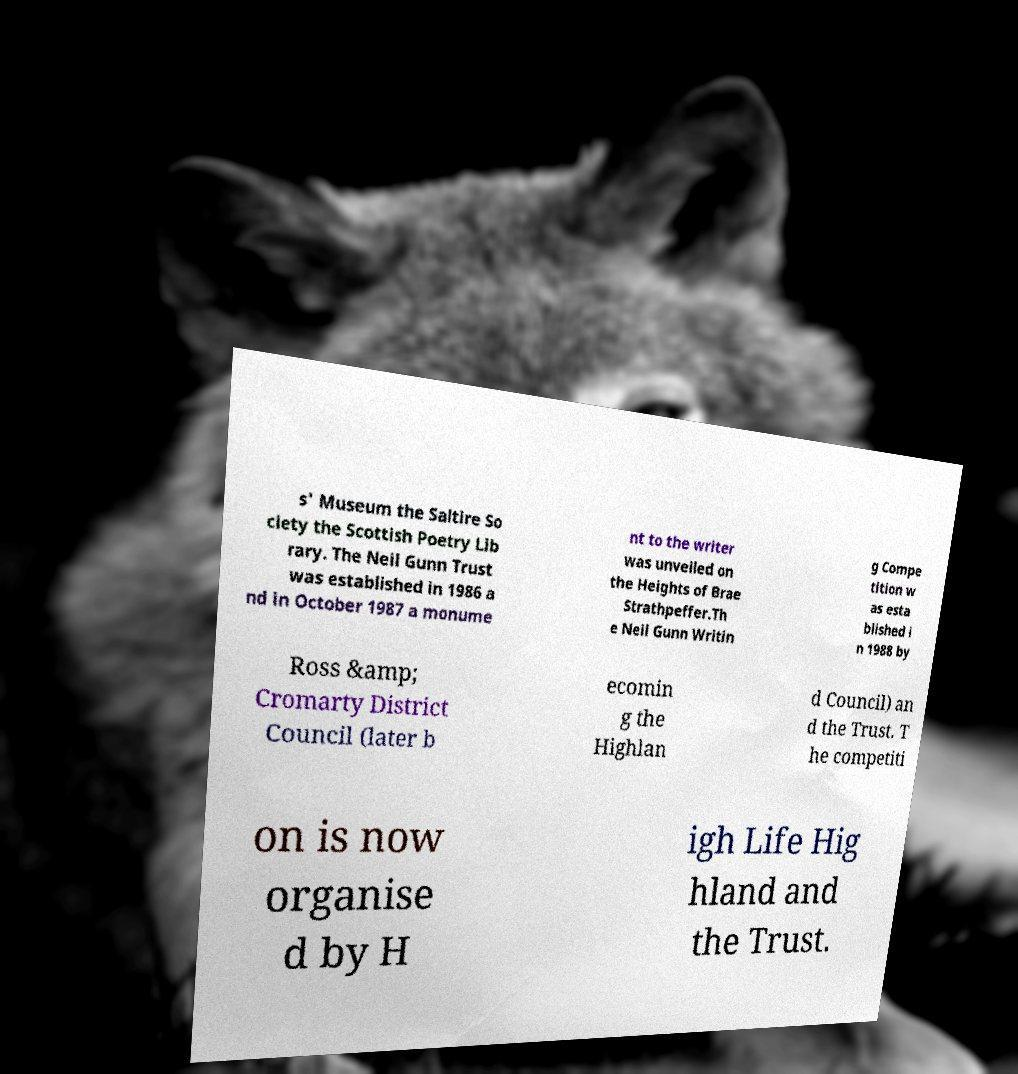What messages or text are displayed in this image? I need them in a readable, typed format. s' Museum the Saltire So ciety the Scottish Poetry Lib rary. The Neil Gunn Trust was established in 1986 a nd in October 1987 a monume nt to the writer was unveiled on the Heights of Brae Strathpeffer.Th e Neil Gunn Writin g Compe tition w as esta blished i n 1988 by Ross &amp; Cromarty District Council (later b ecomin g the Highlan d Council) an d the Trust. T he competiti on is now organise d by H igh Life Hig hland and the Trust. 